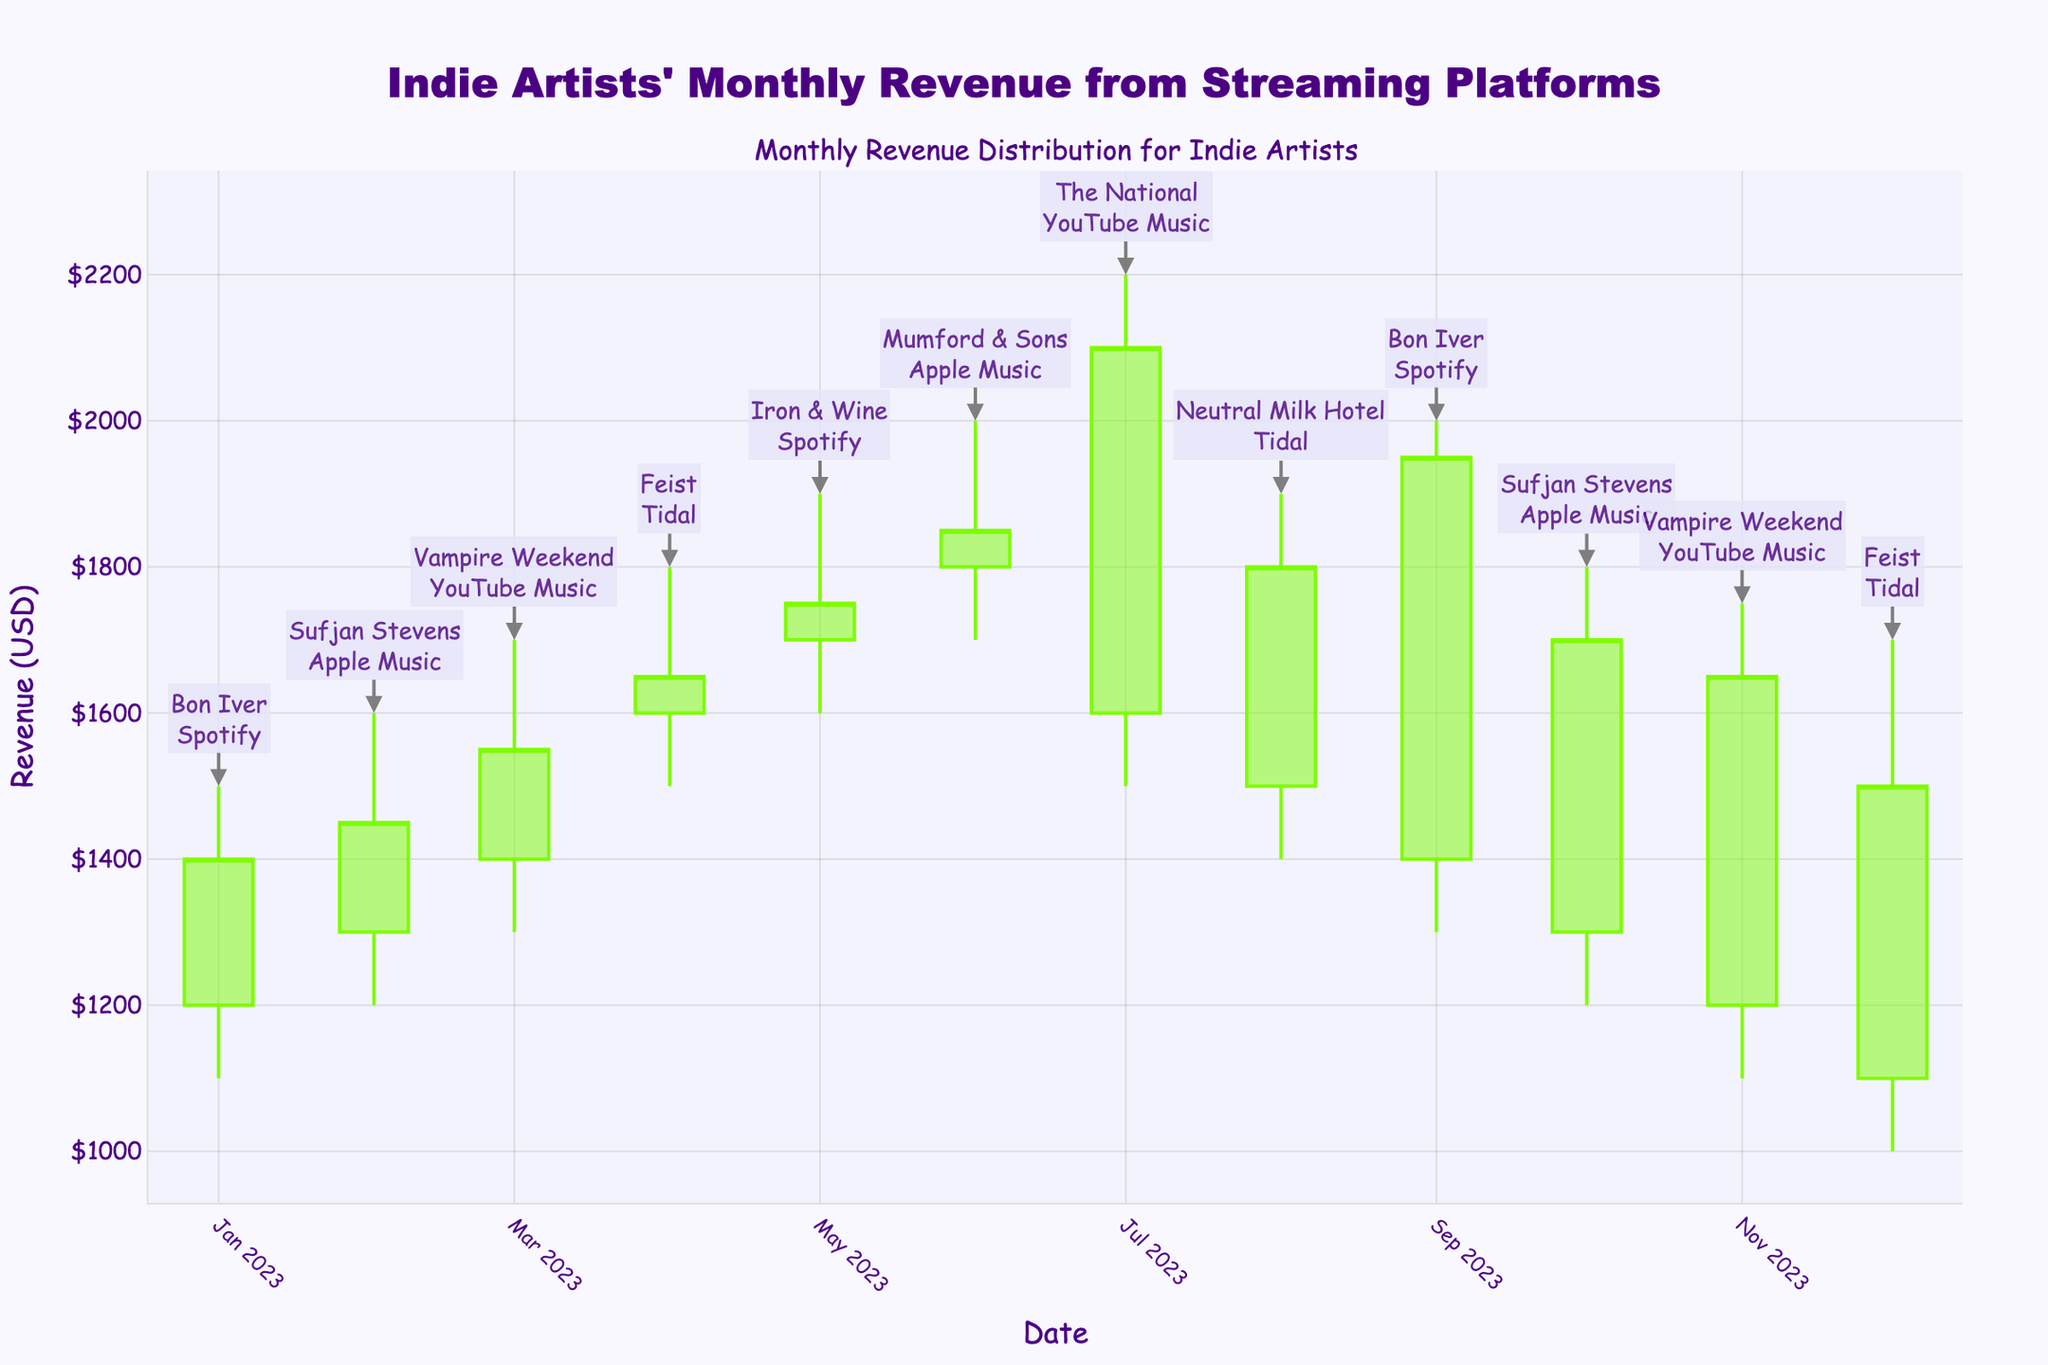what is the title of the candlestick plot? The title is located at the top of the figure, written in a larger and bolder font for emphasis.
Answer: Indie Artists' Monthly Revenue from Streaming Platforms Which month showed the highest revenue peak? To find the month with the highest revenue peak, look for the candlestick with the highest 'High' value, which, in this case, is July 2023.
Answer: July 2023 What is the revenue range for The National in July 2023? To determine the range, subtract the 'Low' value from the 'High' value for July 2023 for The National. The candle shows a 'High' of $2200 and a 'Low' of $1500. The range is $2200 - $1500 = $700.
Answer: $700 Which artist had the lowest closing revenue in December 2023? Check the 'Close' values for December 2023 and look for the lowest one, which is Feist with a closing revenue of $1500.
Answer: Feist Compare Sufjan Stevens's revenue performance in February 2023 and October 2023. Which month was better? Compare the 'Close' values for Sufjan Stevens in February ($1450) and October ($1700). October 2023 has the higher 'Close' value.
Answer: October 2023 How is the month-to-month revenue trend for Bon Iver in January 2023 and September 2023? Compare the 'Close' values for January 2023 ($1400) and September 2023 ($1950) for Bon Iver. The 'Close' value increased from January to September.
Answer: Increasing What is the average peak high revenue among all the artists for the year 2023? To find the average peak high revenue, sum the 'High' values for each month and divide by 12. (1500 + 1600 + 1700 + 1800 + 1900 + 2000 + 2200 + 1900 + 2000 + 1800 + 1750 + 1700) / 12 = 18900 / 12 = 1575
Answer: $1575 Which streaming platform appears most frequently in the highest revenue peaks throughout the year? Identify the months with the highest 'High' values and see which platforms are associated with those months: YouTube Music in July and September. YouTube Music appears in the highest revenue peaks twice.
Answer: YouTube Music Is there a noticeable revenue drop for any artist compared to the previous month? Identify any month where the 'Close' value of that month is significantly lower than the 'Close' value of the previous month. For instance, August shows a 'Close' of $1800 which is lower than July's 'Close' of $2100 for The National.
Answer: Yes, in August 